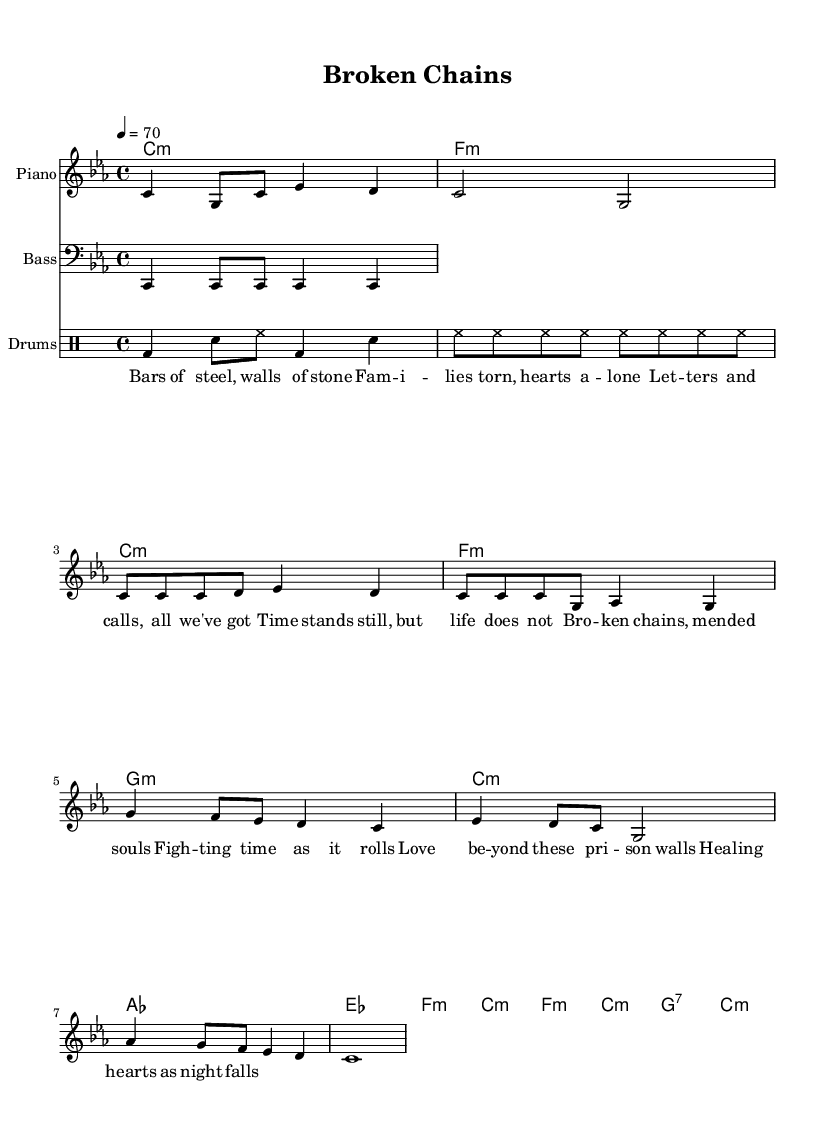What is the key signature of this music? The key signature is C minor, which has three flats (B flat, E flat, and A flat). This is indicated at the beginning of the sheet music.
Answer: C minor What is the time signature of this piece? The time signature is 4/4, which means there are four beats in a measure, and the quarter note gets one beat. This is indicated at the beginning of the music, following the key signature.
Answer: 4/4 What is the tempo marking for this piece? The tempo marking is 4 = 70, meaning there are 70 beats per minute. This is indicated at the beginning of the score after the time signature and key signature.
Answer: 70 How many measures are in the chorus section? The chorus section consists of 4 measures, as can be seen when counting the measures notated in the lyrics and melody above.
Answer: 4 What rhythmic pattern is used in the drum section? The drum section starts with a kick drum (bd), snare (sn), and hi-hat (hh) pattern, which reflects common hip hop beats. This is inferred from the standard notation used in hip hop drumming.
Answer: Kick, snare, hi-hat How do the lyrics reflect the theme of family separation? The lyrics mention "families torn," "hearts alone," and "broken chains," directly addressing the emotional toll of family separation due to incarceration, showcasing pain and resilience.
Answer: Emotional toll What is the overall mood conveyed by the music and lyrics? The overall mood is somber and reflective, conveying deep emotion and longing through both the melodic structure and lyrical content focused on separation and healing.
Answer: Somber 